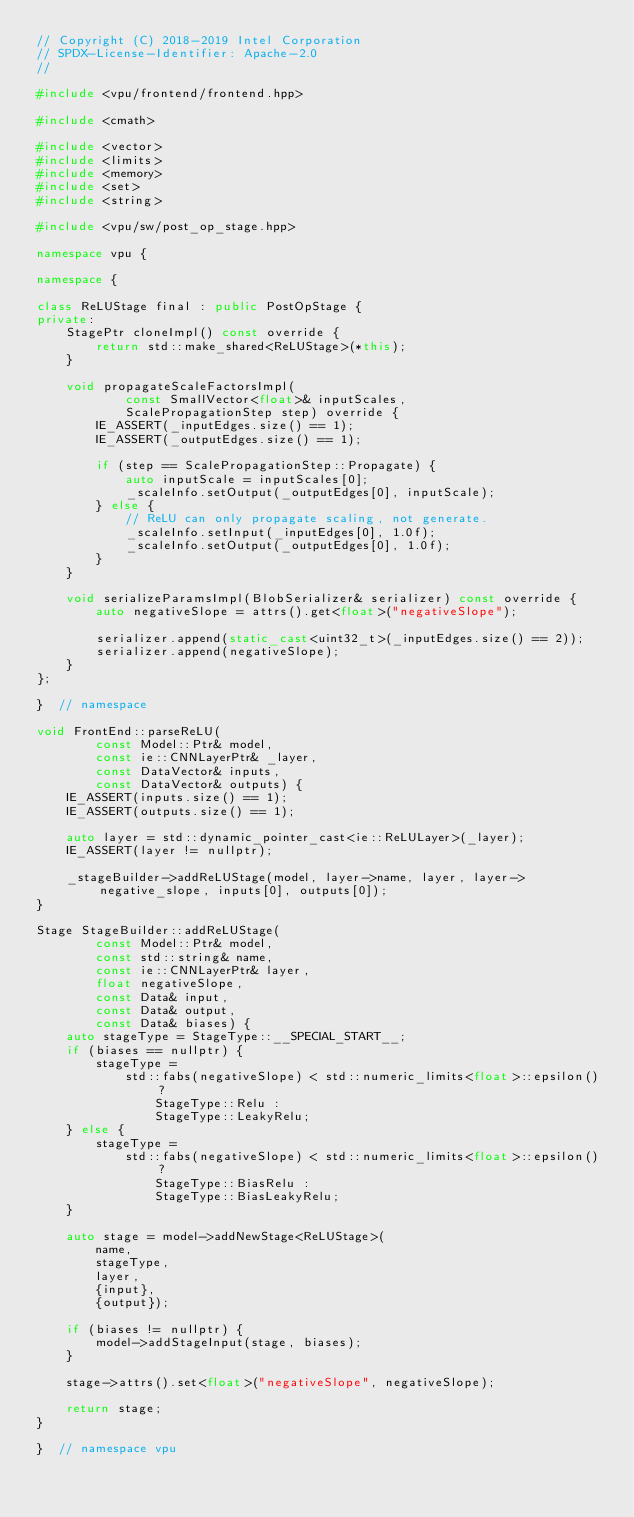<code> <loc_0><loc_0><loc_500><loc_500><_C++_>// Copyright (C) 2018-2019 Intel Corporation
// SPDX-License-Identifier: Apache-2.0
//

#include <vpu/frontend/frontend.hpp>

#include <cmath>

#include <vector>
#include <limits>
#include <memory>
#include <set>
#include <string>

#include <vpu/sw/post_op_stage.hpp>

namespace vpu {

namespace {

class ReLUStage final : public PostOpStage {
private:
    StagePtr cloneImpl() const override {
        return std::make_shared<ReLUStage>(*this);
    }

    void propagateScaleFactorsImpl(
            const SmallVector<float>& inputScales,
            ScalePropagationStep step) override {
        IE_ASSERT(_inputEdges.size() == 1);
        IE_ASSERT(_outputEdges.size() == 1);

        if (step == ScalePropagationStep::Propagate) {
            auto inputScale = inputScales[0];
            _scaleInfo.setOutput(_outputEdges[0], inputScale);
        } else {
            // ReLU can only propagate scaling, not generate.
            _scaleInfo.setInput(_inputEdges[0], 1.0f);
            _scaleInfo.setOutput(_outputEdges[0], 1.0f);
        }
    }

    void serializeParamsImpl(BlobSerializer& serializer) const override {
        auto negativeSlope = attrs().get<float>("negativeSlope");

        serializer.append(static_cast<uint32_t>(_inputEdges.size() == 2));
        serializer.append(negativeSlope);
    }
};

}  // namespace

void FrontEnd::parseReLU(
        const Model::Ptr& model,
        const ie::CNNLayerPtr& _layer,
        const DataVector& inputs,
        const DataVector& outputs) {
    IE_ASSERT(inputs.size() == 1);
    IE_ASSERT(outputs.size() == 1);

    auto layer = std::dynamic_pointer_cast<ie::ReLULayer>(_layer);
    IE_ASSERT(layer != nullptr);

    _stageBuilder->addReLUStage(model, layer->name, layer, layer->negative_slope, inputs[0], outputs[0]);
}

Stage StageBuilder::addReLUStage(
        const Model::Ptr& model,
        const std::string& name,
        const ie::CNNLayerPtr& layer,
        float negativeSlope,
        const Data& input,
        const Data& output,
        const Data& biases) {
    auto stageType = StageType::__SPECIAL_START__;
    if (biases == nullptr) {
        stageType =
            std::fabs(negativeSlope) < std::numeric_limits<float>::epsilon() ?
                StageType::Relu :
                StageType::LeakyRelu;
    } else {
        stageType =
            std::fabs(negativeSlope) < std::numeric_limits<float>::epsilon() ?
                StageType::BiasRelu :
                StageType::BiasLeakyRelu;
    }

    auto stage = model->addNewStage<ReLUStage>(
        name,
        stageType,
        layer,
        {input},
        {output});

    if (biases != nullptr) {
        model->addStageInput(stage, biases);
    }

    stage->attrs().set<float>("negativeSlope", negativeSlope);

    return stage;
}

}  // namespace vpu
</code> 